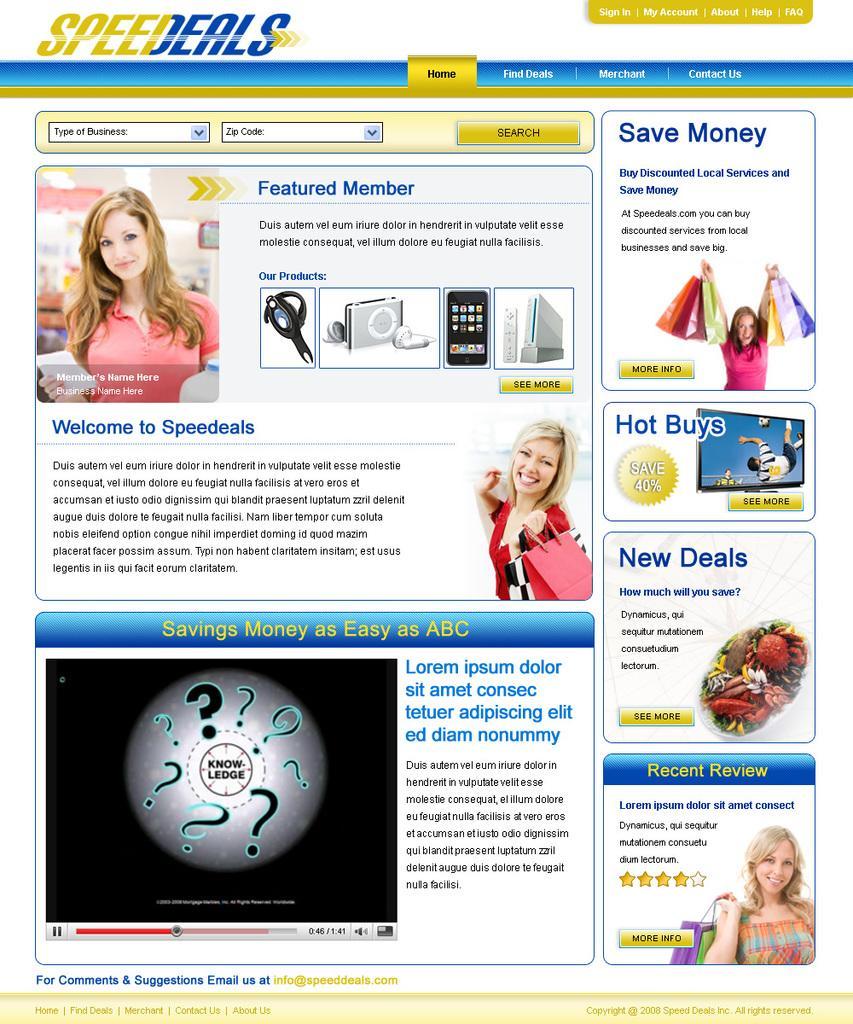In one or two sentences, can you explain what this image depicts? In the center of the image we can see an advertisement. 